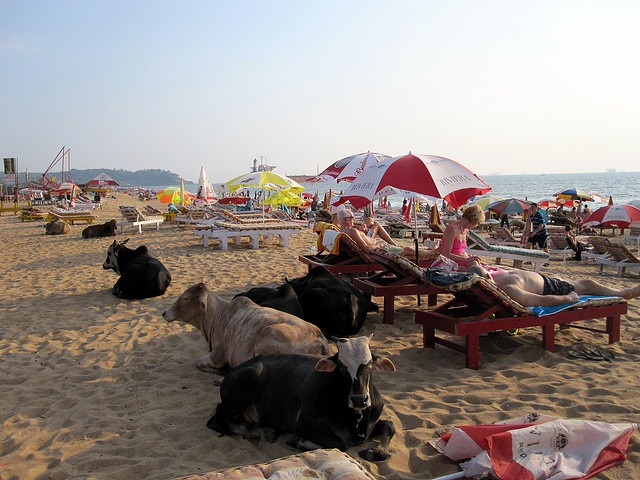Describe the objects in this image and their specific colors. I can see cow in lightblue, black, gray, and maroon tones, bed in lightblue, black, maroon, and gray tones, chair in lightblue, black, maroon, and gray tones, cow in lightblue, black, and gray tones, and umbrella in lightblue, darkgray, brown, lightgray, and maroon tones in this image. 